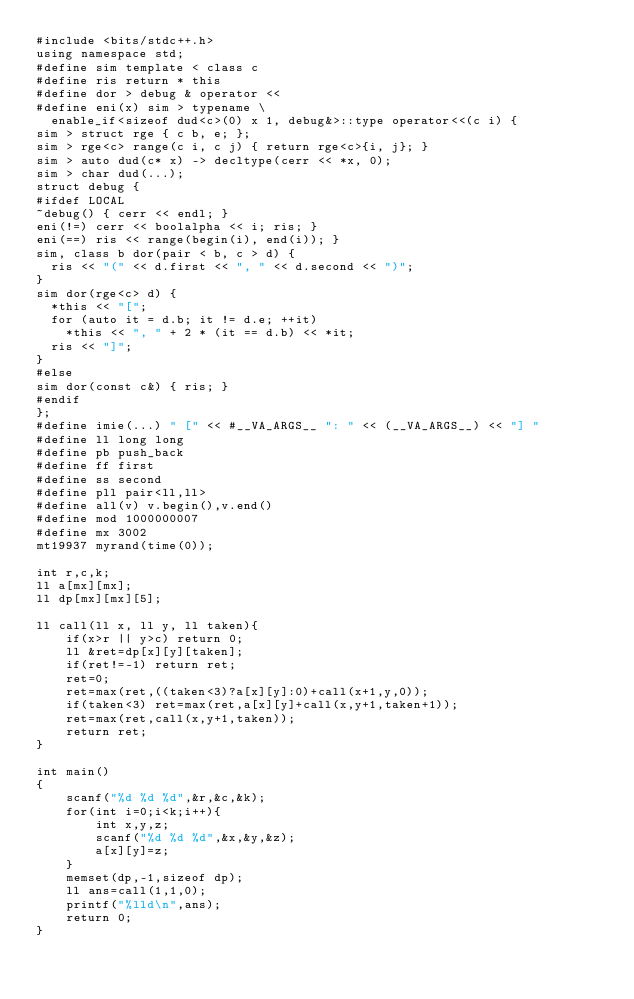Convert code to text. <code><loc_0><loc_0><loc_500><loc_500><_C++_>#include <bits/stdc++.h>
using namespace std;
#define sim template < class c
#define ris return * this
#define dor > debug & operator <<
#define eni(x) sim > typename \
  enable_if<sizeof dud<c>(0) x 1, debug&>::type operator<<(c i) {
sim > struct rge { c b, e; };
sim > rge<c> range(c i, c j) { return rge<c>{i, j}; }
sim > auto dud(c* x) -> decltype(cerr << *x, 0);
sim > char dud(...);
struct debug {
#ifdef LOCAL
~debug() { cerr << endl; }
eni(!=) cerr << boolalpha << i; ris; }
eni(==) ris << range(begin(i), end(i)); }
sim, class b dor(pair < b, c > d) {
  ris << "(" << d.first << ", " << d.second << ")";
}
sim dor(rge<c> d) {
  *this << "[";
  for (auto it = d.b; it != d.e; ++it)
    *this << ", " + 2 * (it == d.b) << *it;
  ris << "]";
}
#else
sim dor(const c&) { ris; }
#endif
};
#define imie(...) " [" << #__VA_ARGS__ ": " << (__VA_ARGS__) << "] "
#define ll long long
#define pb push_back
#define ff first
#define ss second
#define pll pair<ll,ll>
#define all(v) v.begin(),v.end()
#define mod 1000000007
#define mx 3002
mt19937 myrand(time(0));

int r,c,k;
ll a[mx][mx];
ll dp[mx][mx][5];

ll call(ll x, ll y, ll taken){
    if(x>r || y>c) return 0;
    ll &ret=dp[x][y][taken];
    if(ret!=-1) return ret;
    ret=0;
    ret=max(ret,((taken<3)?a[x][y]:0)+call(x+1,y,0));
    if(taken<3) ret=max(ret,a[x][y]+call(x,y+1,taken+1));
    ret=max(ret,call(x,y+1,taken));
    return ret;
}

int main()
{
    scanf("%d %d %d",&r,&c,&k);
    for(int i=0;i<k;i++){
        int x,y,z;
        scanf("%d %d %d",&x,&y,&z);
        a[x][y]=z;
    }
    memset(dp,-1,sizeof dp);
    ll ans=call(1,1,0);
    printf("%lld\n",ans);
    return 0;
}
</code> 